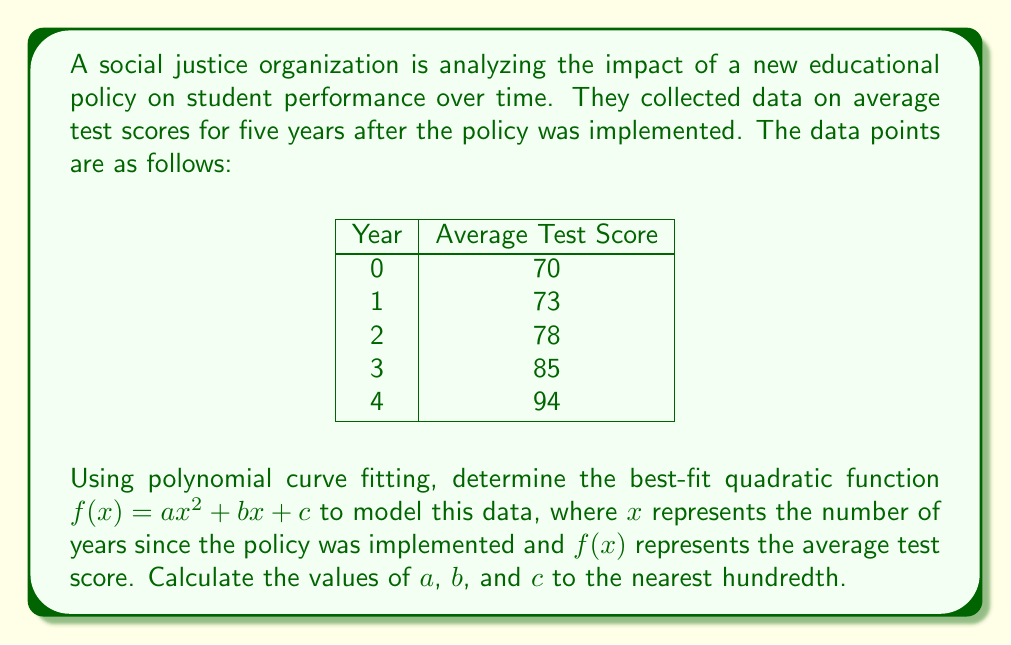Provide a solution to this math problem. To find the best-fit quadratic function, we'll use the method of least squares. Let's follow these steps:

1) We have 5 data points: (0, 70), (1, 73), (2, 78), (3, 85), and (4, 94).

2) For a quadratic function $f(x) = ax^2 + bx + c$, we need to solve the following system of equations:

   $$\sum x^4 a + \sum x^3 b + \sum x^2 c = \sum x^2 y$$
   $$\sum x^3 a + \sum x^2 b + \sum x c = \sum xy$$
   $$\sum x^2 a + \sum x b + n c = \sum y$$

   Where $n$ is the number of data points (5 in this case).

3) Let's calculate the sums:

   $\sum x^4 = 0^4 + 1^4 + 2^4 + 3^4 + 4^4 = 354$
   $\sum x^3 = 0^3 + 1^3 + 2^3 + 3^3 + 4^3 = 100$
   $\sum x^2 = 0^2 + 1^2 + 2^2 + 3^2 + 4^2 = 30$
   $\sum x = 0 + 1 + 2 + 3 + 4 = 10$
   $\sum y = 70 + 73 + 78 + 85 + 94 = 400$
   $\sum x^2y = 0^2(70) + 1^2(73) + 2^2(78) + 3^2(85) + 4^2(94) = 1830$
   $\sum xy = 0(70) + 1(73) + 2(78) + 3(85) + 4(94) = 770$

4) Now we can set up our system of equations:

   $$354a + 100b + 30c = 1830$$
   $$100a + 30b + 10c = 770$$
   $$30a + 10b + 5c = 400$$

5) Solving this system of equations (you can use matrix methods or elimination), we get:

   $a \approx 1.5$
   $b \approx 1.6$
   $c \approx 70.0$

6) Rounding to the nearest hundredth, our final equation is:

   $f(x) = 1.50x^2 + 1.60x + 70.00$
Answer: $a = 1.50$, $b = 1.60$, $c = 70.00$ 